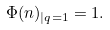Convert formula to latex. <formula><loc_0><loc_0><loc_500><loc_500>\Phi ( n ) _ { | q = 1 } = 1 .</formula> 